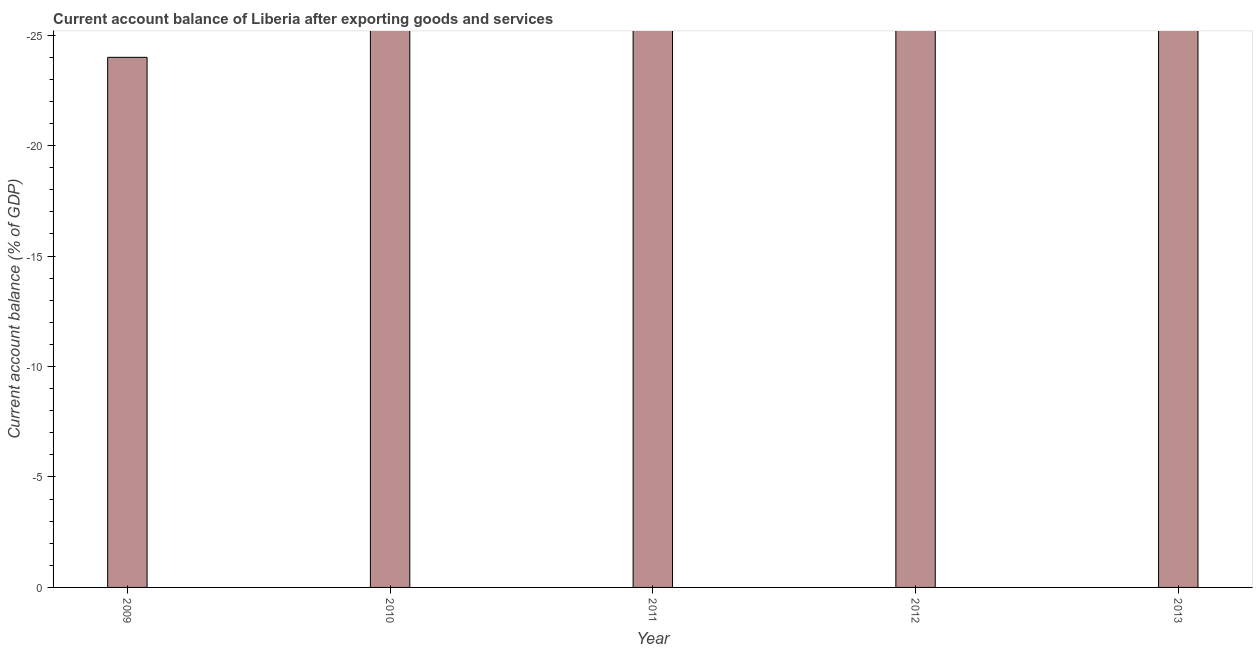Does the graph contain grids?
Keep it short and to the point. No. What is the title of the graph?
Ensure brevity in your answer.  Current account balance of Liberia after exporting goods and services. What is the label or title of the Y-axis?
Provide a short and direct response. Current account balance (% of GDP). What is the current account balance in 2010?
Your answer should be very brief. 0. In how many years, is the current account balance greater than -15 %?
Provide a succinct answer. 0. In how many years, is the current account balance greater than the average current account balance taken over all years?
Your answer should be very brief. 0. Are all the bars in the graph horizontal?
Provide a short and direct response. No. How many years are there in the graph?
Offer a terse response. 5. What is the difference between two consecutive major ticks on the Y-axis?
Offer a terse response. 5. What is the Current account balance (% of GDP) in 2010?
Your response must be concise. 0. What is the Current account balance (% of GDP) in 2013?
Your answer should be very brief. 0. 